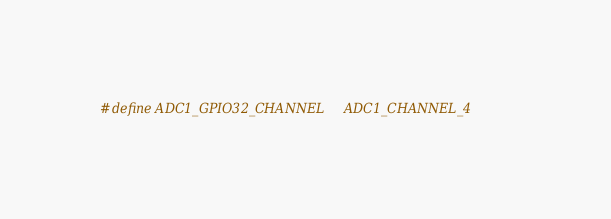Convert code to text. <code><loc_0><loc_0><loc_500><loc_500><_C_>
#define ADC1_GPIO32_CHANNEL     ADC1_CHANNEL_4</code> 